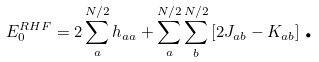<formula> <loc_0><loc_0><loc_500><loc_500>E _ { 0 } ^ { R H F } = 2 \sum _ { a } ^ { N / 2 } h _ { a a } + \sum _ { a } ^ { N / 2 } \sum _ { b } ^ { N / 2 } \left [ 2 J _ { a b } - K _ { a b } \right ] \text {.}</formula> 